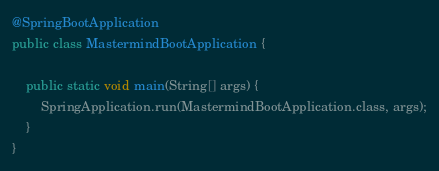<code> <loc_0><loc_0><loc_500><loc_500><_Java_>@SpringBootApplication
public class MastermindBootApplication {

	public static void main(String[] args) {
		SpringApplication.run(MastermindBootApplication.class, args);
	}
}
</code> 